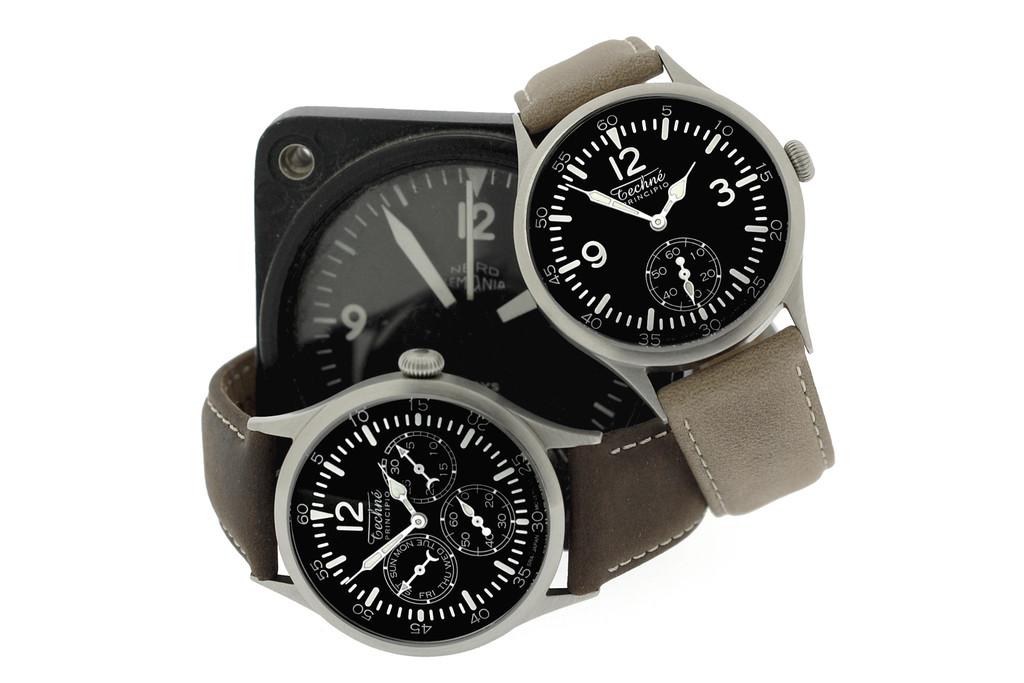What is the time shown on the watch on the top right?
Provide a short and direct response. 1:54. What number is printed on the bottom watch?
Your response must be concise. 12. 